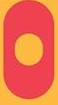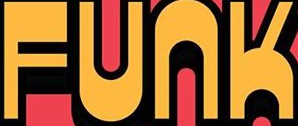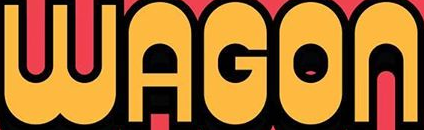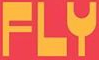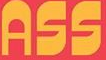What words are shown in these images in order, separated by a semicolon? O; FUNK; WAGON; FLY; ASS 